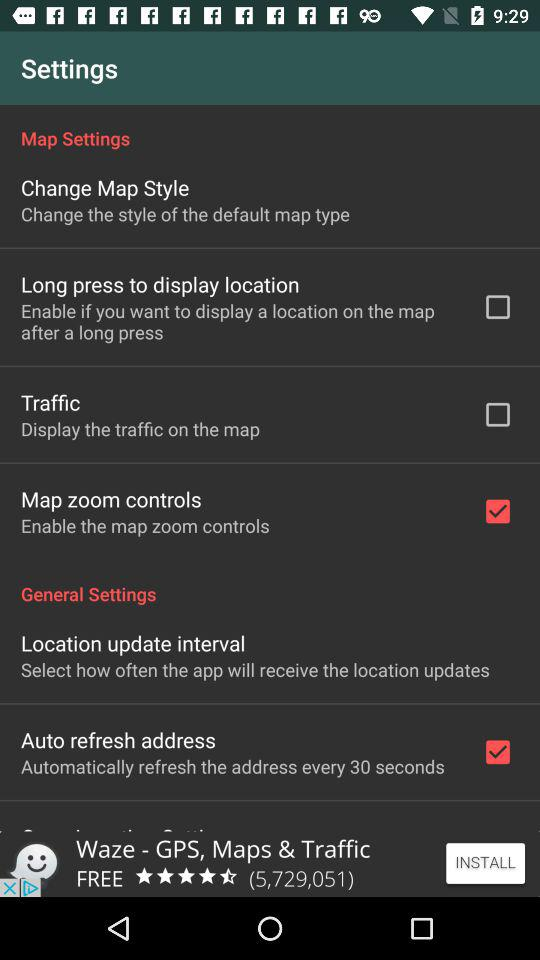How often will the app receive location updates?
When the provided information is insufficient, respond with <no answer>. <no answer> 